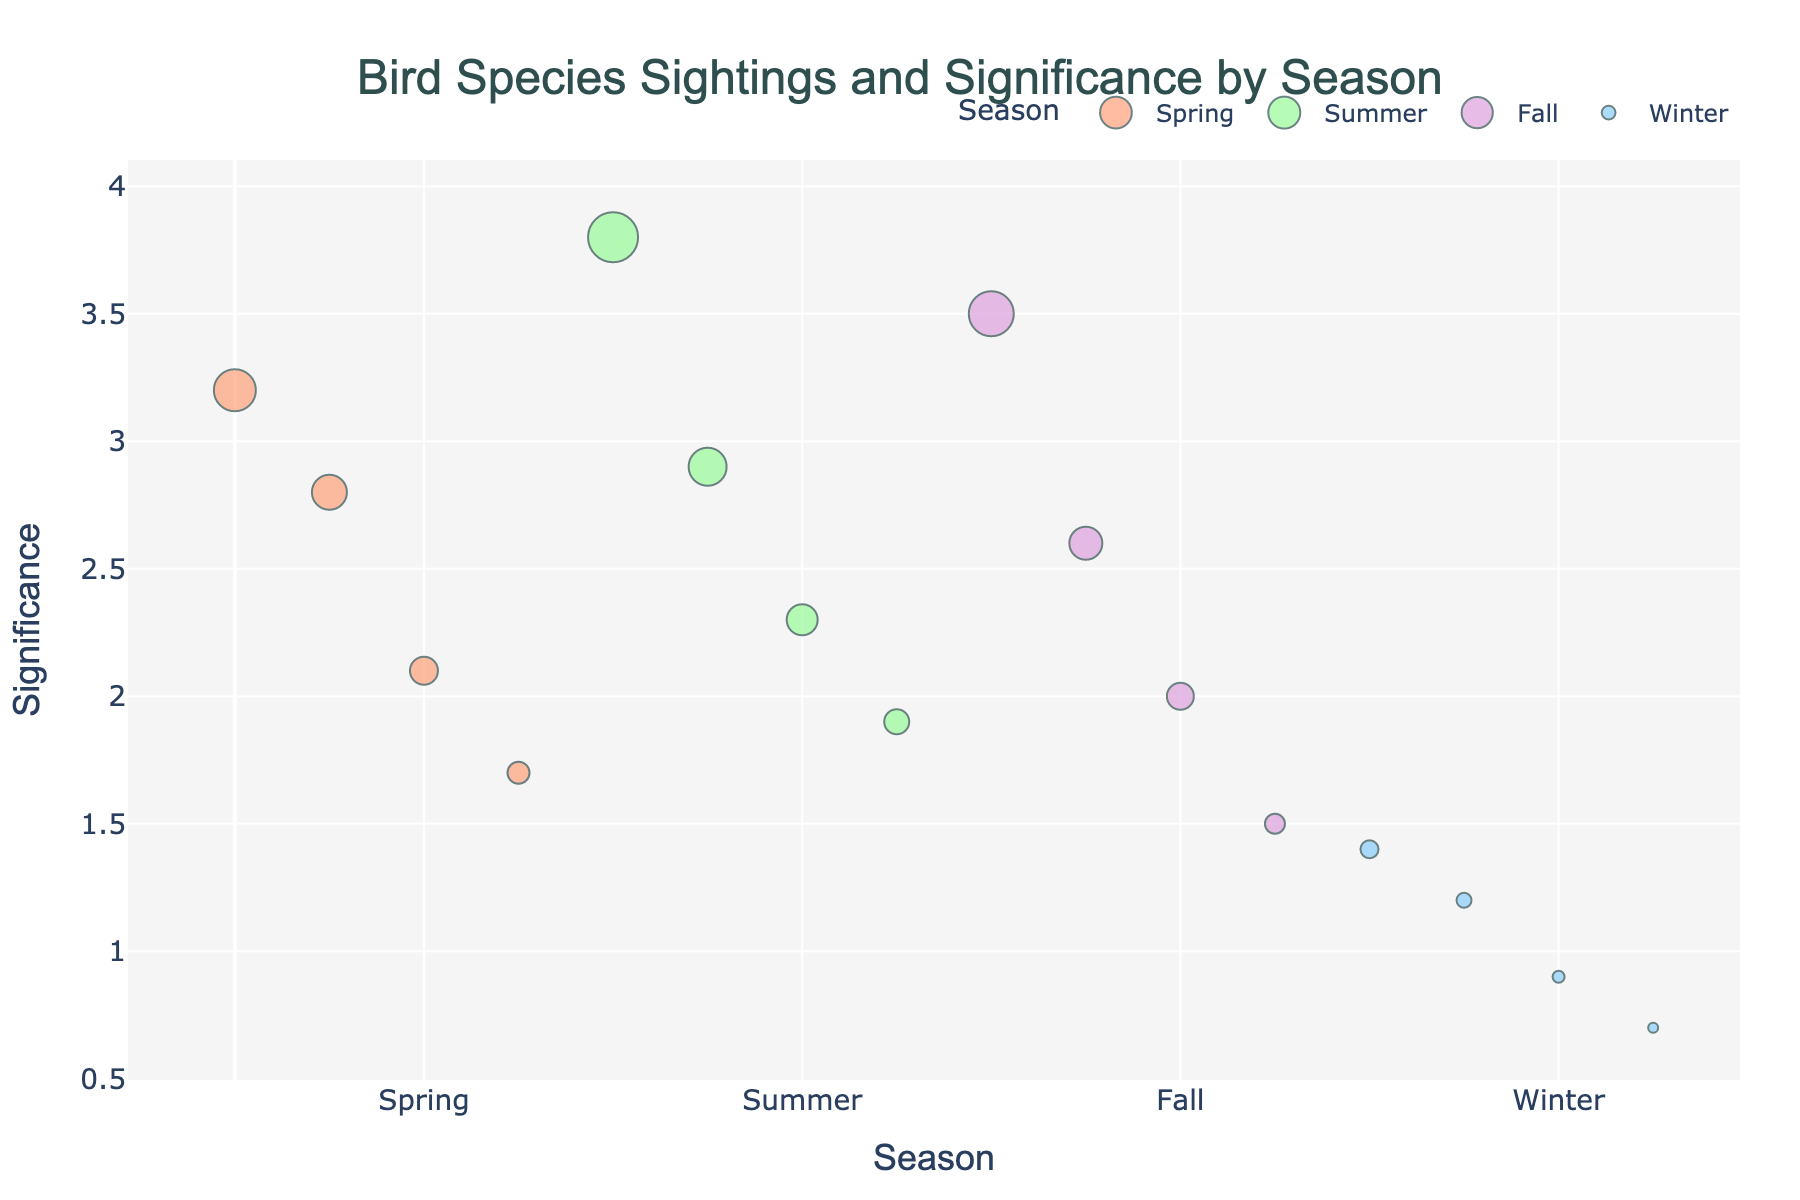What's the title of the figure? The title of the figure is displayed at the top and reads 'Bird Species Sightings and Significance by Season'.
Answer: Bird Species Sightings and Significance by Season How many seasons are represented in the plot? There are four seasons represented on the x-axis, which are 'Spring', 'Summer', 'Fall', and 'Winter'.
Answer: Four Which bird species had the highest significance in Summer? By looking at the 'Summer' season's data points and their significance values on the y-axis, the highest value (3.8) is associated with the 'American Goldfinch'.
Answer: American Goldfinch What is the significance value of the Northern Cardinal in Spring? Locate the 'Spring' season, find 'Northern Cardinal' among the labels, and look at its corresponding significance value on the y-axis, which is 2.8.
Answer: 2.8 Compare the sightings of the American Robin in Spring and the Dark-eyed Junco in Fall, which is higher? The sightings of the American Robin (42) in Spring and the Dark-eyed Junco (45) in Fall can be compared by referring to the size of the markers or referring directly to their values. The Dark-eyed Junco has more sightings.
Answer: Dark-eyed Junco What is the average significance value of bird sightings in Winter? The significance values for Winter are 1.4, 1.2, 0.9, and 0.7. The average is calculated as (1.4 + 1.2 + 0.9 + 0.7) / 4 = 1.05.
Answer: 1.05 Which season has the lowest overall significance values? By comparing the ranges of significance values on the y-axis for each season, Winter has the lowest overall values (ranging from 0.7 to 1.4).
Answer: Winter Is there any bird species in Fall with a significance value less than 2? In Fall, the only bird species that falls below the significance value of 2 is the 'European Starling' with a significance of 1.5.
Answer: Yes, European Starling Which bird species in Spring has the least number of sightings, and what is its corresponding significance value? The bird with the least sightings in Spring is the 'House Finch' with 22 sightings, and its significance value is 1.7.
Answer: House Finch, 1.7 Find the bird species with the highest sightings in Winter. What is its significance value? In Winter, the 'Downy Woodpecker' has the highest sightings (18), with a corresponding significance value of 1.4.
Answer: Downy Woodpecker, 1.4 